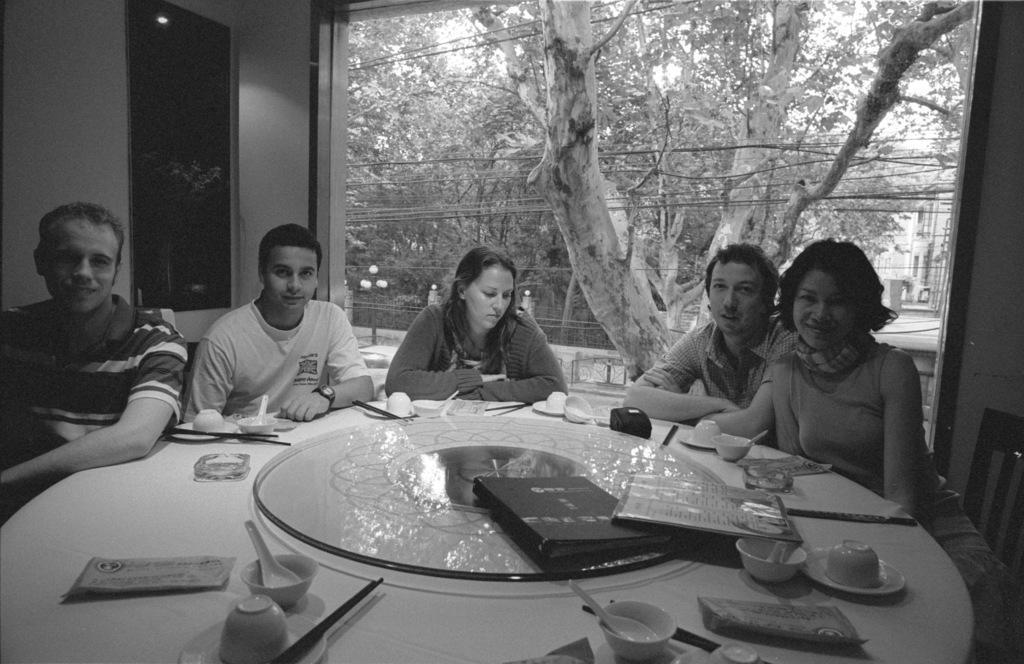Please provide a concise description of this image. In this picture we can see five people sitting on chairs and in front of them there is table and on table we can see bowls, spoon, cup, saucer, chopstick, menu card, book and in background we can see trees, wires, building, poster. 